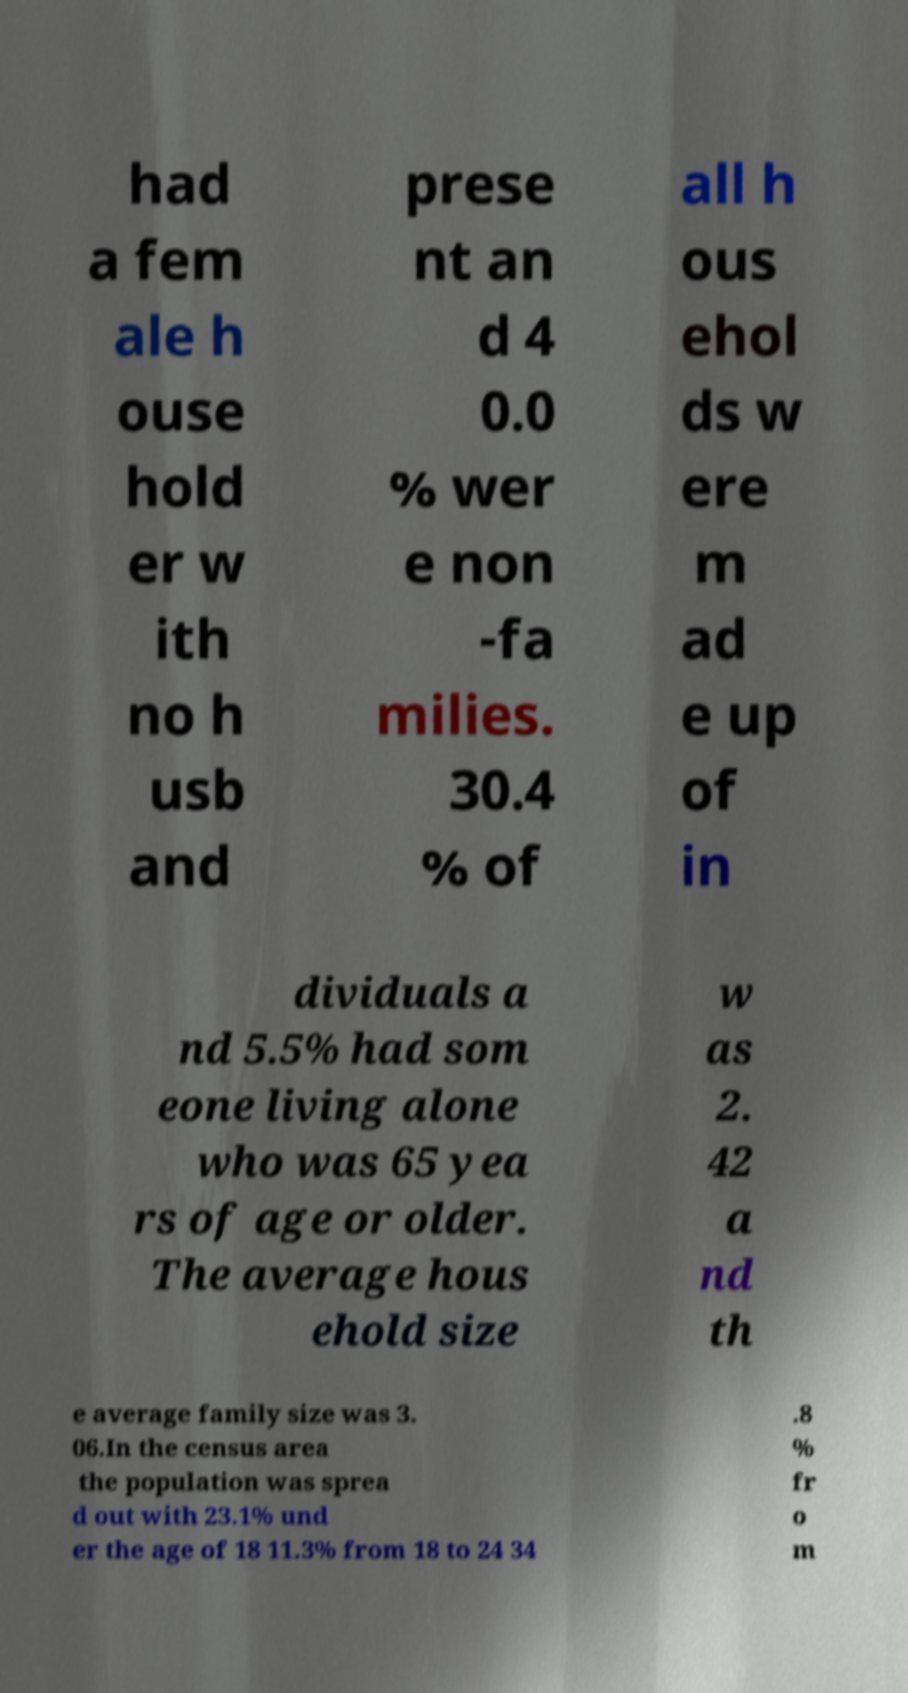For documentation purposes, I need the text within this image transcribed. Could you provide that? had a fem ale h ouse hold er w ith no h usb and prese nt an d 4 0.0 % wer e non -fa milies. 30.4 % of all h ous ehol ds w ere m ad e up of in dividuals a nd 5.5% had som eone living alone who was 65 yea rs of age or older. The average hous ehold size w as 2. 42 a nd th e average family size was 3. 06.In the census area the population was sprea d out with 23.1% und er the age of 18 11.3% from 18 to 24 34 .8 % fr o m 